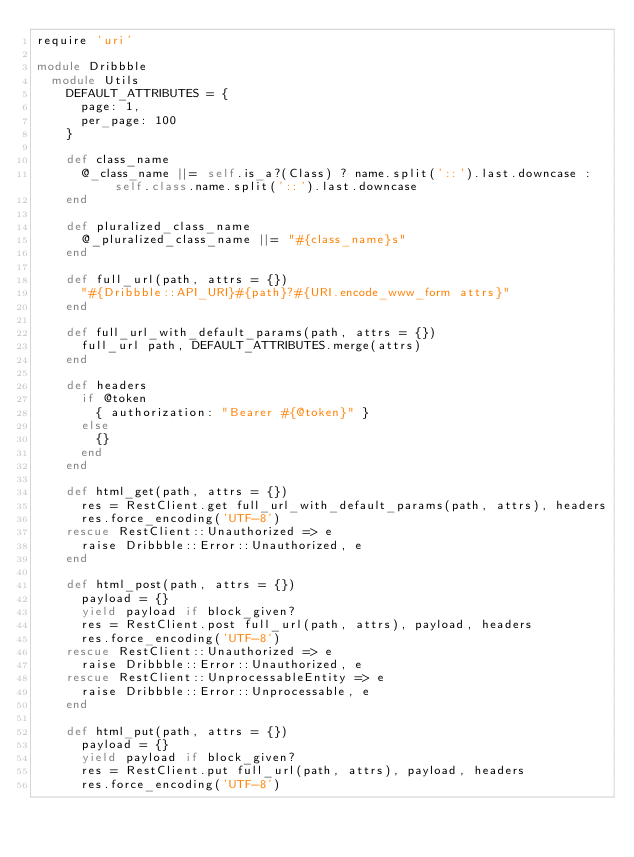Convert code to text. <code><loc_0><loc_0><loc_500><loc_500><_Ruby_>require 'uri'

module Dribbble
  module Utils
    DEFAULT_ATTRIBUTES = {
      page: 1,
      per_page: 100
    }

    def class_name
      @_class_name ||= self.is_a?(Class) ? name.split('::').last.downcase : self.class.name.split('::').last.downcase
    end

    def pluralized_class_name
      @_pluralized_class_name ||= "#{class_name}s"
    end

    def full_url(path, attrs = {})
      "#{Dribbble::API_URI}#{path}?#{URI.encode_www_form attrs}"
    end

    def full_url_with_default_params(path, attrs = {})
      full_url path, DEFAULT_ATTRIBUTES.merge(attrs)
    end

    def headers
      if @token
        { authorization: "Bearer #{@token}" }
      else
        {}
      end
    end

    def html_get(path, attrs = {})
      res = RestClient.get full_url_with_default_params(path, attrs), headers
      res.force_encoding('UTF-8')
    rescue RestClient::Unauthorized => e
      raise Dribbble::Error::Unauthorized, e
    end

    def html_post(path, attrs = {})
      payload = {}
      yield payload if block_given?
      res = RestClient.post full_url(path, attrs), payload, headers
      res.force_encoding('UTF-8')
    rescue RestClient::Unauthorized => e
      raise Dribbble::Error::Unauthorized, e
    rescue RestClient::UnprocessableEntity => e
      raise Dribbble::Error::Unprocessable, e
    end

    def html_put(path, attrs = {})
      payload = {}
      yield payload if block_given?
      res = RestClient.put full_url(path, attrs), payload, headers
      res.force_encoding('UTF-8')</code> 